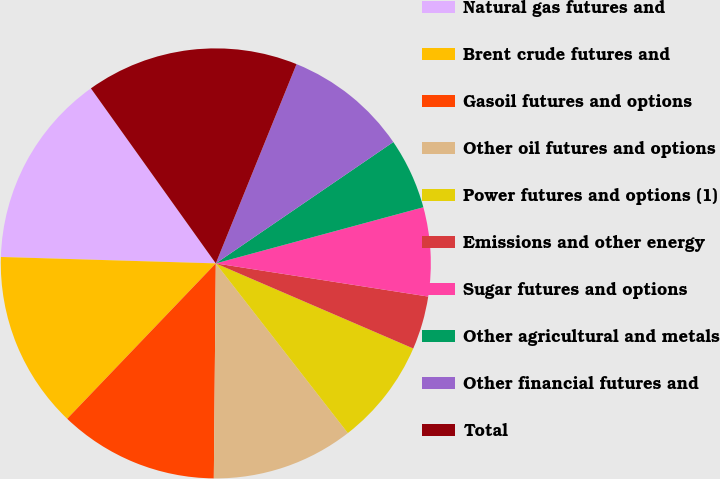<chart> <loc_0><loc_0><loc_500><loc_500><pie_chart><fcel>Natural gas futures and<fcel>Brent crude futures and<fcel>Gasoil futures and options<fcel>Other oil futures and options<fcel>Power futures and options (1)<fcel>Emissions and other energy<fcel>Sugar futures and options<fcel>Other agricultural and metals<fcel>Other financial futures and<fcel>Total<nl><fcel>14.66%<fcel>13.33%<fcel>12.0%<fcel>10.67%<fcel>8.0%<fcel>4.01%<fcel>6.67%<fcel>5.34%<fcel>9.33%<fcel>15.99%<nl></chart> 